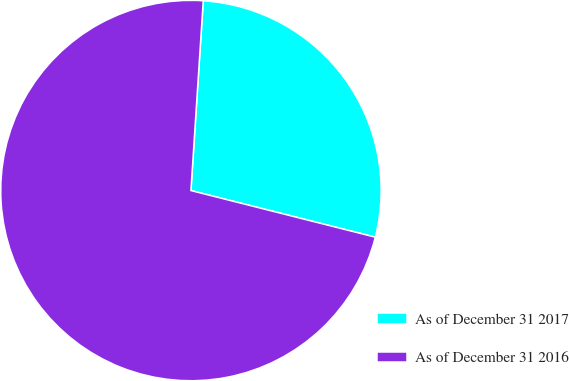Convert chart. <chart><loc_0><loc_0><loc_500><loc_500><pie_chart><fcel>As of December 31 2017<fcel>As of December 31 2016<nl><fcel>27.91%<fcel>72.09%<nl></chart> 